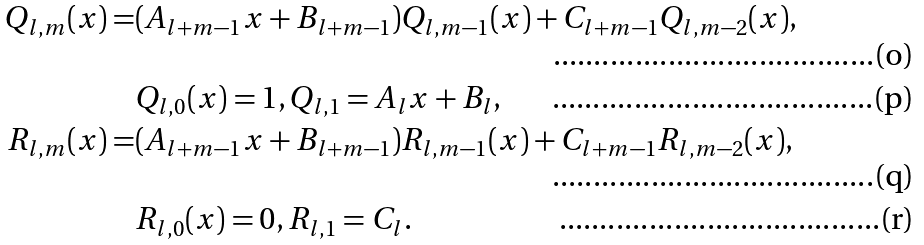Convert formula to latex. <formula><loc_0><loc_0><loc_500><loc_500>Q _ { l , m } ( x ) = & ( A _ { l + m - 1 } x + B _ { l + m - 1 } ) Q _ { l , m - 1 } ( x ) + C _ { l + m - 1 } Q _ { l , m - 2 } ( x ) , \\ & Q _ { l , 0 } ( x ) = 1 , Q _ { l , 1 } = A _ { l } x + B _ { l } , \\ R _ { l , m } ( x ) = & ( A _ { l + m - 1 } x + B _ { l + m - 1 } ) R _ { l , m - 1 } ( x ) + C _ { l + m - 1 } R _ { l , m - 2 } ( x ) , \\ & R _ { l , 0 } ( x ) = 0 , R _ { l , 1 } = C _ { l } .</formula> 